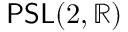Convert formula to latex. <formula><loc_0><loc_0><loc_500><loc_500>P S L ( 2 , \mathbb { R } )</formula> 